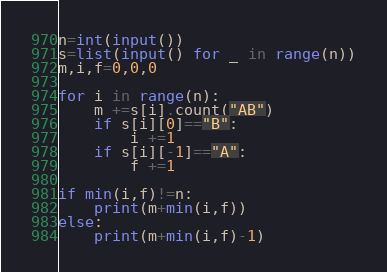Convert code to text. <code><loc_0><loc_0><loc_500><loc_500><_Python_>n=int(input())
s=list(input() for _ in range(n))
m,i,f=0,0,0

for i in range(n):
    m +=s[i].count("AB")
    if s[i][0]=="B":
        i +=1
    if s[i][-1]=="A":
        f +=1

if min(i,f)!=n:
    print(m+min(i,f))
else:
    print(m+min(i,f)-1)
</code> 